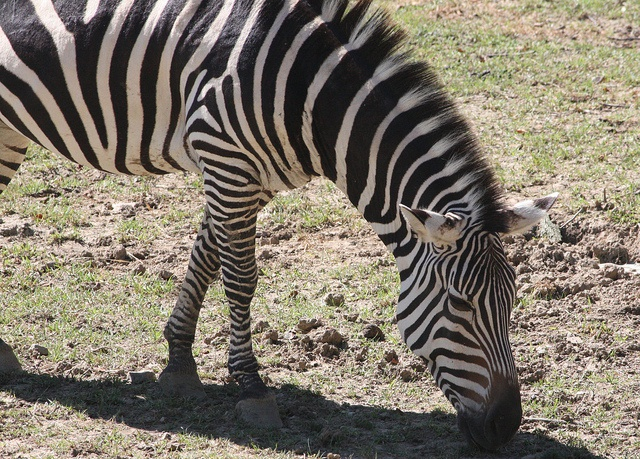Describe the objects in this image and their specific colors. I can see a zebra in gray, black, and darkgray tones in this image. 